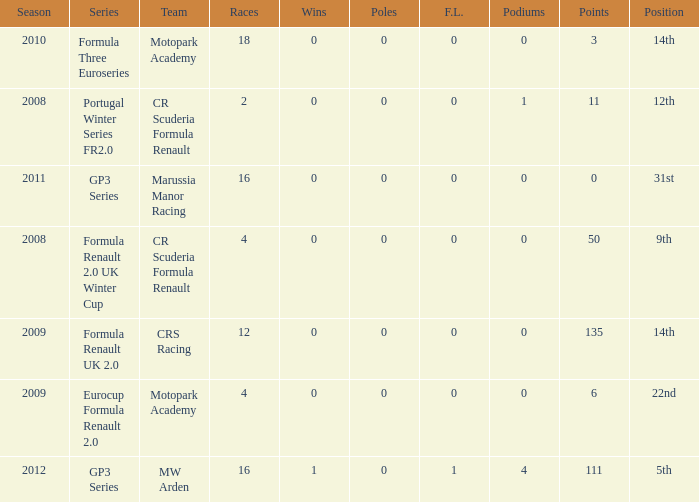What are the most poles listed? 0.0. 